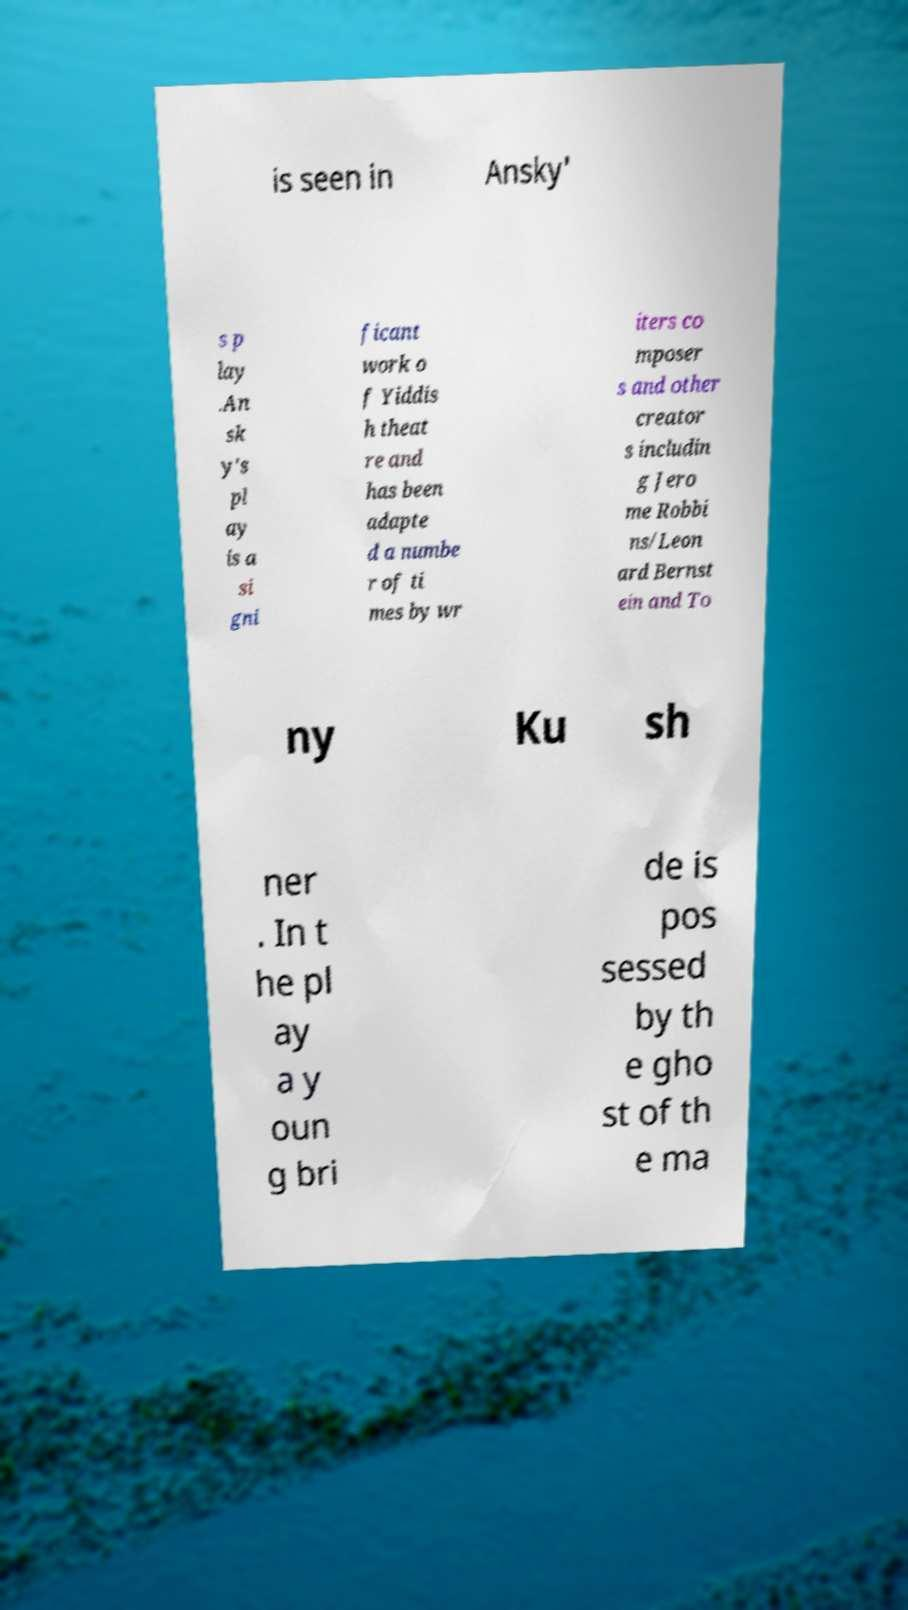There's text embedded in this image that I need extracted. Can you transcribe it verbatim? is seen in Ansky' s p lay .An sk y's pl ay is a si gni ficant work o f Yiddis h theat re and has been adapte d a numbe r of ti mes by wr iters co mposer s and other creator s includin g Jero me Robbi ns/Leon ard Bernst ein and To ny Ku sh ner . In t he pl ay a y oun g bri de is pos sessed by th e gho st of th e ma 